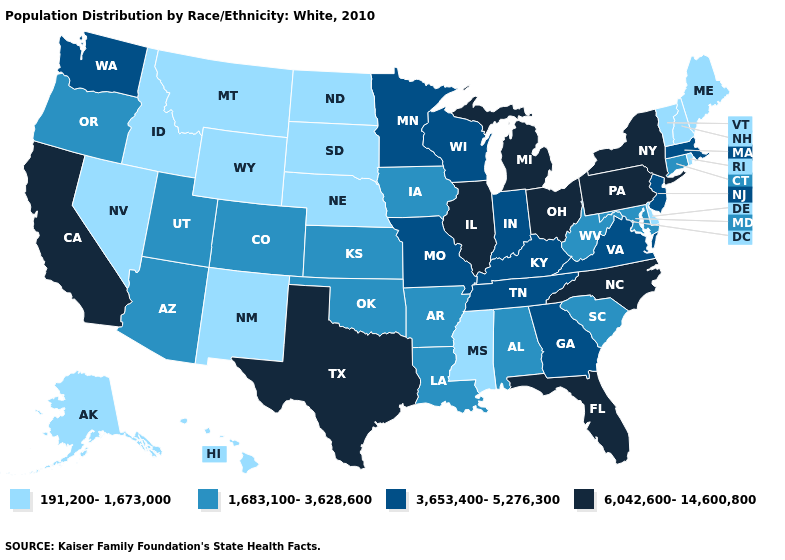Name the states that have a value in the range 191,200-1,673,000?
Be succinct. Alaska, Delaware, Hawaii, Idaho, Maine, Mississippi, Montana, Nebraska, Nevada, New Hampshire, New Mexico, North Dakota, Rhode Island, South Dakota, Vermont, Wyoming. Name the states that have a value in the range 3,653,400-5,276,300?
Answer briefly. Georgia, Indiana, Kentucky, Massachusetts, Minnesota, Missouri, New Jersey, Tennessee, Virginia, Washington, Wisconsin. Name the states that have a value in the range 191,200-1,673,000?
Give a very brief answer. Alaska, Delaware, Hawaii, Idaho, Maine, Mississippi, Montana, Nebraska, Nevada, New Hampshire, New Mexico, North Dakota, Rhode Island, South Dakota, Vermont, Wyoming. What is the value of New Mexico?
Answer briefly. 191,200-1,673,000. Does Rhode Island have a lower value than New Mexico?
Concise answer only. No. Does Florida have the lowest value in the USA?
Short answer required. No. Name the states that have a value in the range 6,042,600-14,600,800?
Write a very short answer. California, Florida, Illinois, Michigan, New York, North Carolina, Ohio, Pennsylvania, Texas. Name the states that have a value in the range 1,683,100-3,628,600?
Keep it brief. Alabama, Arizona, Arkansas, Colorado, Connecticut, Iowa, Kansas, Louisiana, Maryland, Oklahoma, Oregon, South Carolina, Utah, West Virginia. Which states have the highest value in the USA?
Keep it brief. California, Florida, Illinois, Michigan, New York, North Carolina, Ohio, Pennsylvania, Texas. Does Nebraska have the highest value in the MidWest?
Be succinct. No. Does the first symbol in the legend represent the smallest category?
Give a very brief answer. Yes. Which states have the highest value in the USA?
Quick response, please. California, Florida, Illinois, Michigan, New York, North Carolina, Ohio, Pennsylvania, Texas. What is the lowest value in states that border Oregon?
Concise answer only. 191,200-1,673,000. What is the value of Alabama?
Answer briefly. 1,683,100-3,628,600. Name the states that have a value in the range 6,042,600-14,600,800?
Concise answer only. California, Florida, Illinois, Michigan, New York, North Carolina, Ohio, Pennsylvania, Texas. 